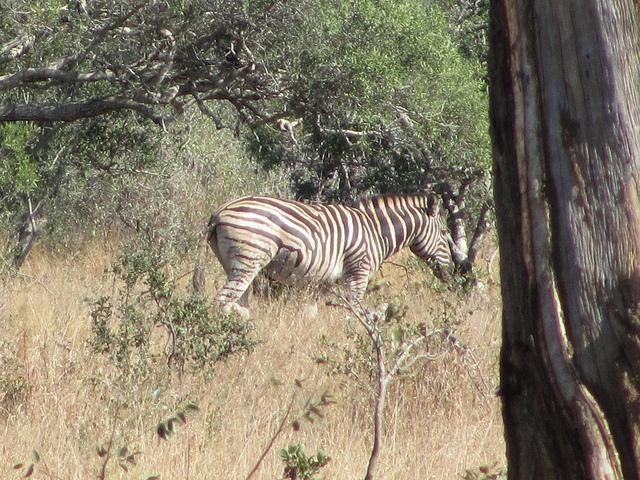What is the color of the zebra?
Write a very short answer. Black and white. What color is the grass?
Quick response, please. Brown. How many zebras?
Write a very short answer. 1. How many zebras are shown?
Quick response, please. 1. What color is the door?
Short answer required. No door. Is this a safe habitat for a human to be in?
Short answer required. No. Where was this taken?
Concise answer only. Africa. Where are the zebras?
Give a very brief answer. Outside. 